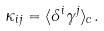<formula> <loc_0><loc_0><loc_500><loc_500>\kappa _ { i j } = \langle \delta ^ { i } \gamma ^ { j } \rangle _ { c } .</formula> 